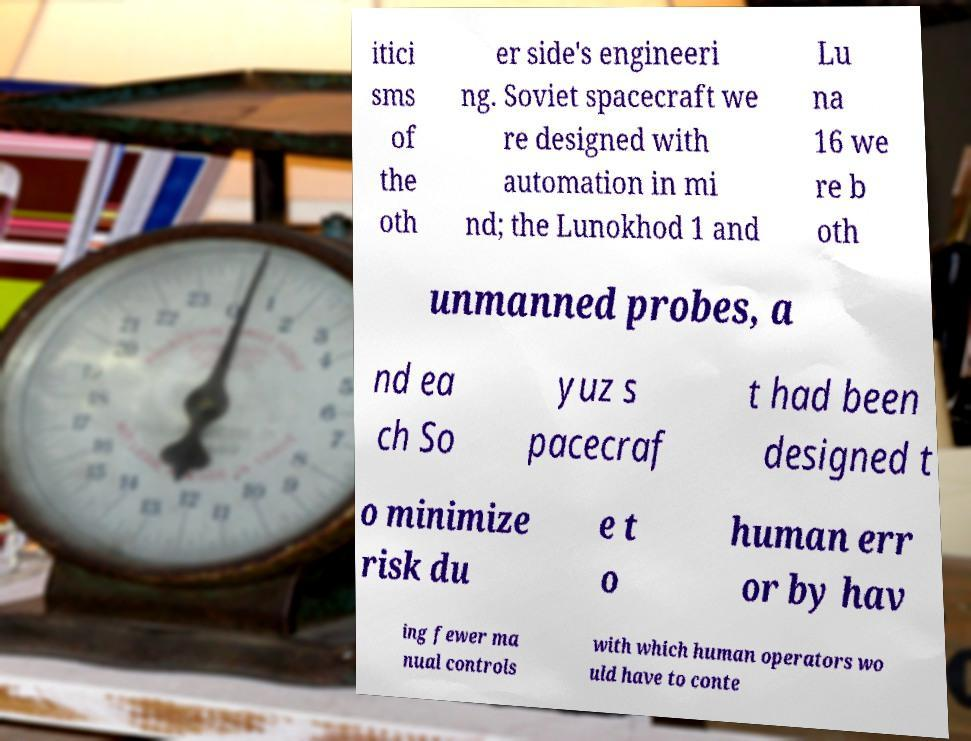For documentation purposes, I need the text within this image transcribed. Could you provide that? itici sms of the oth er side's engineeri ng. Soviet spacecraft we re designed with automation in mi nd; the Lunokhod 1 and Lu na 16 we re b oth unmanned probes, a nd ea ch So yuz s pacecraf t had been designed t o minimize risk du e t o human err or by hav ing fewer ma nual controls with which human operators wo uld have to conte 